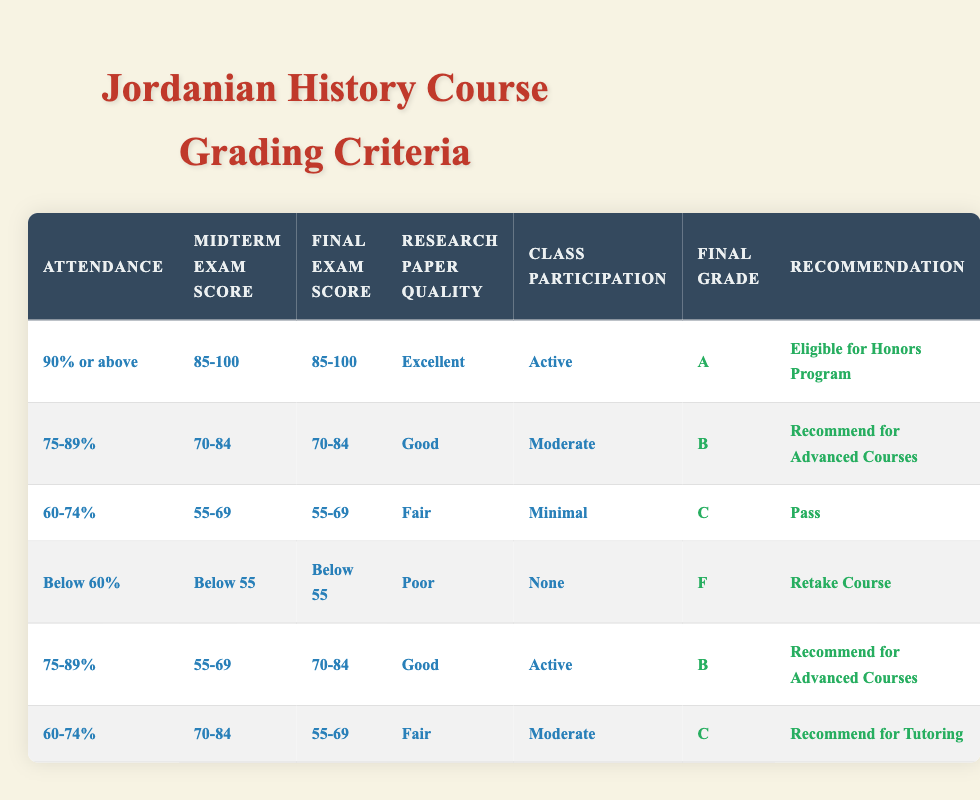What is the final grade for a student with 90% attendance, scoring 90 on both exams, submitting an excellent research paper, and actively participating in class? According to the rules, students with 90% or above attendance, 85-100 on midterm and final exams, excellent research paper quality, and active class participation receive an "A" as their final grade.
Answer: A How many students would receive a recommendation for advanced courses? There are two rules that result in a recommendation for advanced courses: one for students with 75-89% attendance and scores of 70-84, and another for students with 75-89% attendance, scoring 55-69 on the midterm and 70-84 on the final, while receiving a good research quality and actively participating. Both conditions apply to a total of three scenarios in the table.
Answer: 3 Is a student who has below 60% attendance guaranteed to pass? According to the rules, if a student has below 60% attendance accompanied by low scores in both exams and poor research, they receive an "F" and must retake the course. Thus, it is not guaranteed that they would pass.
Answer: No What is the grade for a student who attends 80% of the classes and scores 75 on the midterm, 80 on the final, with a good research paper but has only minimal class participation? The rules show that a student with 75-89% attendance, 70-84 in the midterm, and 70-84 in the final, coupled with a good quality paper but minimal participation results in a "B" grade.
Answer: B If 60% of the students fall in the "C" category, how many students might that represent in a class of 30? To find out the number of students in the "C" category, calculate 60% of 30, which is 0.6 * 30 = 18.
Answer: 18 